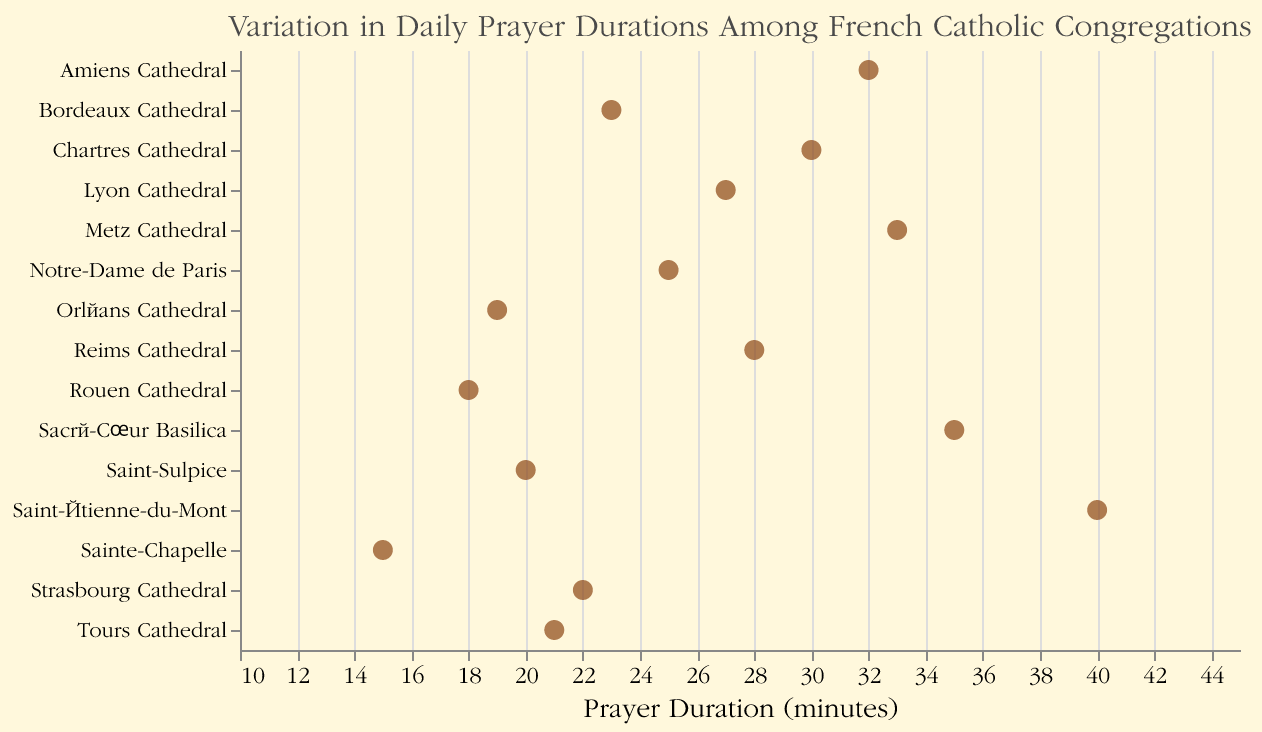How many congregations have a daily prayer duration greater than 30 minutes? To find this, identify all points with a prayer duration greater than 30 on the x-axis of the plot. The congregations are: Sacré-Cœur Basilica (35), Saint-Étienne-du-Mont (40), Amiens Cathedral (32), Metz Cathedral (33). So, there are 4 congregations.
Answer: 4 Which congregation has the shortest prayer duration? Locate the point farthest to the left on the x-axis, which represents the smallest prayer duration. This point corresponds to Sainte-Chapelle with a prayer duration of 15 minutes.
Answer: Sainte-Chapelle What is the range of the prayer durations? The range is the difference between the maximum and minimum values. The maximum duration is 40 minutes (Saint-Étienne-du-Mont), and the minimum duration is 15 minutes (Sainte-Chapelle). Therefore, the range is 40 - 15 = 25 minutes.
Answer: 25 minutes What is the median prayer duration? To find the median, organize the durations in ascending order: 15, 18, 19, 20, 21, 22, 23, 25, 27, 28, 30, 32, 33, 35, 40. The median is the middle value in an odd-numbered list; the 8th value here is 25 minutes.
Answer: 25 minutes Which two congregations have the closest prayer durations and what is the difference between them? Identify the pair with the smallest difference between their prayer durations. Saint-Sulpice (20) and Tours Cathedral (21) have the smallest difference of 1 minute.
Answer: Saint-Sulpice and Tours Cathedral, 1 minute What is the average prayer duration among all congregations? Sum all prayer durations: 25 + 35 + 30 + 20 + 28 + 15 + 22 + 18 + 40 + 32 + 23 + 27 + 19 + 21 + 33 = 388. Divide by the number of congregations: 388 / 15 = roughly 25.9 minutes.
Answer: 25.9 minutes (rounded) Which congregation has the highest prayer duration? Locate the point farthest to the right on the x-axis, which represents the largest prayer duration. This point corresponds to Saint-Étienne-du-Mont with a prayer duration of 40 minutes.
Answer: Saint-Étienne-du-Mont Describe the overall distribution of prayer durations? The plot shows a generally wide range of prayer durations from 15 minutes to 40 minutes. Most congregations have durations spanning between 15 and 35 minutes, with a higher concentration around the middle values than on the extremes.
Answer: Wide distribution, concentrated around middle values How many congregations have a prayer duration of exactly 20 minutes or less? Count the points at or to the left of 20 on the x-axis: Sainte-Chapelle (15), Rouen Cathedral (18), Orléans Cathedral (19), Saint-Sulpice (20) sum up to 4 congregations.
Answer: 4 